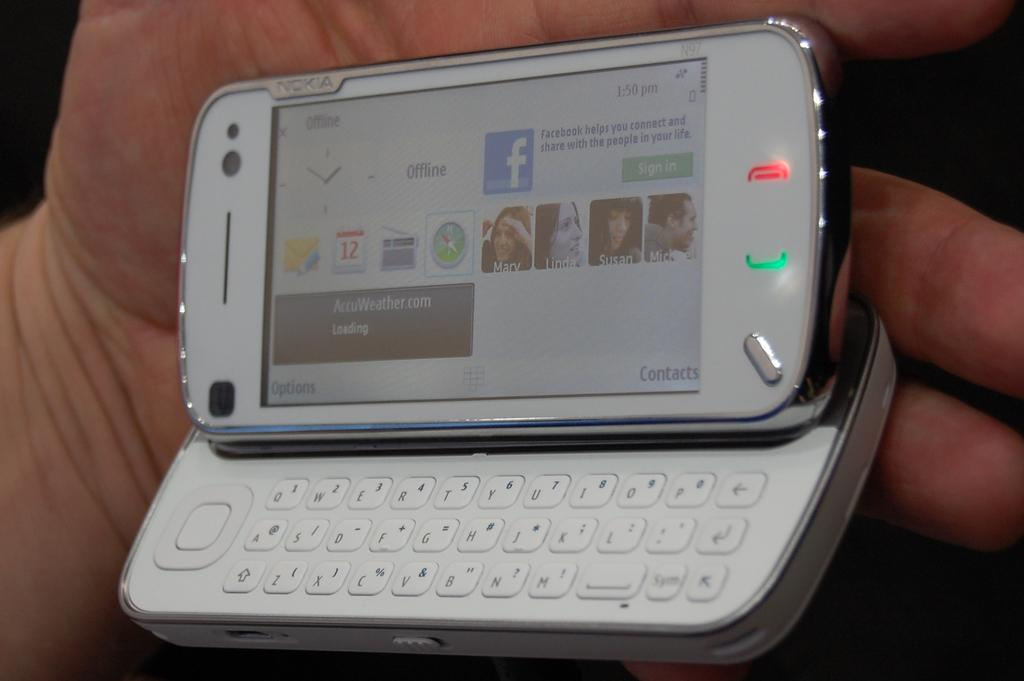<image>
Write a terse but informative summary of the picture. a phone with an image of Mary on it 